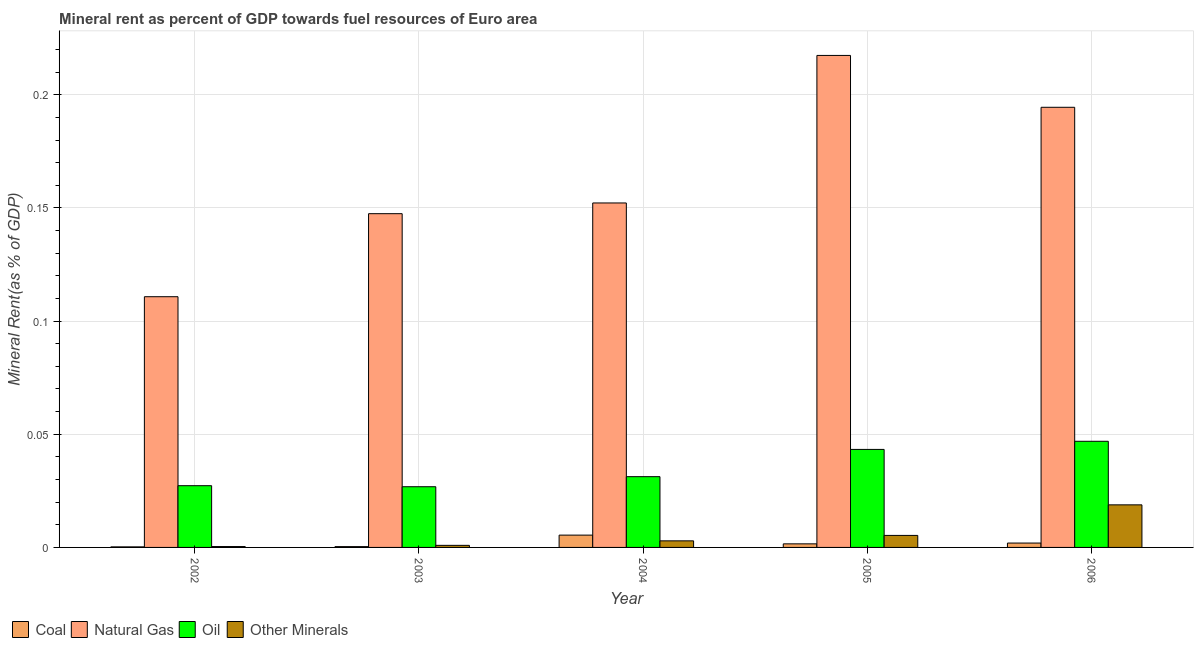How many different coloured bars are there?
Provide a short and direct response. 4. How many groups of bars are there?
Your answer should be very brief. 5. Are the number of bars on each tick of the X-axis equal?
Ensure brevity in your answer.  Yes. What is the  rent of other minerals in 2005?
Your answer should be compact. 0.01. Across all years, what is the maximum natural gas rent?
Your response must be concise. 0.22. Across all years, what is the minimum oil rent?
Your answer should be very brief. 0.03. What is the total natural gas rent in the graph?
Make the answer very short. 0.82. What is the difference between the natural gas rent in 2004 and that in 2006?
Keep it short and to the point. -0.04. What is the difference between the oil rent in 2002 and the  rent of other minerals in 2006?
Your answer should be compact. -0.02. What is the average  rent of other minerals per year?
Provide a short and direct response. 0.01. What is the ratio of the natural gas rent in 2003 to that in 2006?
Your answer should be compact. 0.76. What is the difference between the highest and the second highest  rent of other minerals?
Offer a very short reply. 0.01. What is the difference between the highest and the lowest oil rent?
Keep it short and to the point. 0.02. What does the 1st bar from the left in 2005 represents?
Provide a short and direct response. Coal. What does the 3rd bar from the right in 2006 represents?
Your answer should be very brief. Natural Gas. Are all the bars in the graph horizontal?
Provide a short and direct response. No. How many years are there in the graph?
Ensure brevity in your answer.  5. Does the graph contain any zero values?
Your response must be concise. No. Does the graph contain grids?
Offer a very short reply. Yes. What is the title of the graph?
Offer a terse response. Mineral rent as percent of GDP towards fuel resources of Euro area. What is the label or title of the X-axis?
Ensure brevity in your answer.  Year. What is the label or title of the Y-axis?
Make the answer very short. Mineral Rent(as % of GDP). What is the Mineral Rent(as % of GDP) in Coal in 2002?
Your response must be concise. 0. What is the Mineral Rent(as % of GDP) of Natural Gas in 2002?
Offer a terse response. 0.11. What is the Mineral Rent(as % of GDP) of Oil in 2002?
Give a very brief answer. 0.03. What is the Mineral Rent(as % of GDP) in Other Minerals in 2002?
Keep it short and to the point. 0. What is the Mineral Rent(as % of GDP) in Coal in 2003?
Provide a succinct answer. 0. What is the Mineral Rent(as % of GDP) of Natural Gas in 2003?
Your answer should be very brief. 0.15. What is the Mineral Rent(as % of GDP) of Oil in 2003?
Ensure brevity in your answer.  0.03. What is the Mineral Rent(as % of GDP) of Other Minerals in 2003?
Your response must be concise. 0. What is the Mineral Rent(as % of GDP) in Coal in 2004?
Ensure brevity in your answer.  0.01. What is the Mineral Rent(as % of GDP) of Natural Gas in 2004?
Provide a succinct answer. 0.15. What is the Mineral Rent(as % of GDP) of Oil in 2004?
Offer a very short reply. 0.03. What is the Mineral Rent(as % of GDP) in Other Minerals in 2004?
Keep it short and to the point. 0. What is the Mineral Rent(as % of GDP) in Coal in 2005?
Provide a succinct answer. 0. What is the Mineral Rent(as % of GDP) in Natural Gas in 2005?
Keep it short and to the point. 0.22. What is the Mineral Rent(as % of GDP) in Oil in 2005?
Your answer should be compact. 0.04. What is the Mineral Rent(as % of GDP) in Other Minerals in 2005?
Offer a terse response. 0.01. What is the Mineral Rent(as % of GDP) in Coal in 2006?
Provide a succinct answer. 0. What is the Mineral Rent(as % of GDP) of Natural Gas in 2006?
Provide a succinct answer. 0.19. What is the Mineral Rent(as % of GDP) in Oil in 2006?
Provide a succinct answer. 0.05. What is the Mineral Rent(as % of GDP) of Other Minerals in 2006?
Keep it short and to the point. 0.02. Across all years, what is the maximum Mineral Rent(as % of GDP) of Coal?
Your answer should be compact. 0.01. Across all years, what is the maximum Mineral Rent(as % of GDP) in Natural Gas?
Provide a succinct answer. 0.22. Across all years, what is the maximum Mineral Rent(as % of GDP) in Oil?
Keep it short and to the point. 0.05. Across all years, what is the maximum Mineral Rent(as % of GDP) in Other Minerals?
Provide a succinct answer. 0.02. Across all years, what is the minimum Mineral Rent(as % of GDP) in Coal?
Offer a terse response. 0. Across all years, what is the minimum Mineral Rent(as % of GDP) of Natural Gas?
Provide a succinct answer. 0.11. Across all years, what is the minimum Mineral Rent(as % of GDP) of Oil?
Offer a very short reply. 0.03. Across all years, what is the minimum Mineral Rent(as % of GDP) in Other Minerals?
Give a very brief answer. 0. What is the total Mineral Rent(as % of GDP) in Coal in the graph?
Keep it short and to the point. 0.01. What is the total Mineral Rent(as % of GDP) in Natural Gas in the graph?
Your response must be concise. 0.82. What is the total Mineral Rent(as % of GDP) in Oil in the graph?
Your answer should be compact. 0.18. What is the total Mineral Rent(as % of GDP) of Other Minerals in the graph?
Make the answer very short. 0.03. What is the difference between the Mineral Rent(as % of GDP) in Coal in 2002 and that in 2003?
Your answer should be very brief. -0. What is the difference between the Mineral Rent(as % of GDP) of Natural Gas in 2002 and that in 2003?
Give a very brief answer. -0.04. What is the difference between the Mineral Rent(as % of GDP) of Other Minerals in 2002 and that in 2003?
Provide a succinct answer. -0. What is the difference between the Mineral Rent(as % of GDP) of Coal in 2002 and that in 2004?
Give a very brief answer. -0.01. What is the difference between the Mineral Rent(as % of GDP) of Natural Gas in 2002 and that in 2004?
Provide a succinct answer. -0.04. What is the difference between the Mineral Rent(as % of GDP) in Oil in 2002 and that in 2004?
Ensure brevity in your answer.  -0. What is the difference between the Mineral Rent(as % of GDP) in Other Minerals in 2002 and that in 2004?
Your answer should be compact. -0. What is the difference between the Mineral Rent(as % of GDP) in Coal in 2002 and that in 2005?
Provide a succinct answer. -0. What is the difference between the Mineral Rent(as % of GDP) in Natural Gas in 2002 and that in 2005?
Provide a succinct answer. -0.11. What is the difference between the Mineral Rent(as % of GDP) of Oil in 2002 and that in 2005?
Your response must be concise. -0.02. What is the difference between the Mineral Rent(as % of GDP) of Other Minerals in 2002 and that in 2005?
Your answer should be very brief. -0. What is the difference between the Mineral Rent(as % of GDP) in Coal in 2002 and that in 2006?
Your answer should be very brief. -0. What is the difference between the Mineral Rent(as % of GDP) in Natural Gas in 2002 and that in 2006?
Make the answer very short. -0.08. What is the difference between the Mineral Rent(as % of GDP) in Oil in 2002 and that in 2006?
Your answer should be compact. -0.02. What is the difference between the Mineral Rent(as % of GDP) of Other Minerals in 2002 and that in 2006?
Offer a terse response. -0.02. What is the difference between the Mineral Rent(as % of GDP) in Coal in 2003 and that in 2004?
Your response must be concise. -0.01. What is the difference between the Mineral Rent(as % of GDP) in Natural Gas in 2003 and that in 2004?
Give a very brief answer. -0. What is the difference between the Mineral Rent(as % of GDP) of Oil in 2003 and that in 2004?
Your answer should be very brief. -0. What is the difference between the Mineral Rent(as % of GDP) in Other Minerals in 2003 and that in 2004?
Your answer should be very brief. -0. What is the difference between the Mineral Rent(as % of GDP) in Coal in 2003 and that in 2005?
Provide a short and direct response. -0. What is the difference between the Mineral Rent(as % of GDP) in Natural Gas in 2003 and that in 2005?
Your response must be concise. -0.07. What is the difference between the Mineral Rent(as % of GDP) in Oil in 2003 and that in 2005?
Offer a terse response. -0.02. What is the difference between the Mineral Rent(as % of GDP) of Other Minerals in 2003 and that in 2005?
Your answer should be compact. -0. What is the difference between the Mineral Rent(as % of GDP) of Coal in 2003 and that in 2006?
Offer a terse response. -0. What is the difference between the Mineral Rent(as % of GDP) of Natural Gas in 2003 and that in 2006?
Offer a terse response. -0.05. What is the difference between the Mineral Rent(as % of GDP) in Oil in 2003 and that in 2006?
Make the answer very short. -0.02. What is the difference between the Mineral Rent(as % of GDP) of Other Minerals in 2003 and that in 2006?
Your response must be concise. -0.02. What is the difference between the Mineral Rent(as % of GDP) in Coal in 2004 and that in 2005?
Keep it short and to the point. 0. What is the difference between the Mineral Rent(as % of GDP) of Natural Gas in 2004 and that in 2005?
Keep it short and to the point. -0.07. What is the difference between the Mineral Rent(as % of GDP) of Oil in 2004 and that in 2005?
Your answer should be very brief. -0.01. What is the difference between the Mineral Rent(as % of GDP) in Other Minerals in 2004 and that in 2005?
Make the answer very short. -0. What is the difference between the Mineral Rent(as % of GDP) of Coal in 2004 and that in 2006?
Offer a very short reply. 0. What is the difference between the Mineral Rent(as % of GDP) in Natural Gas in 2004 and that in 2006?
Your answer should be very brief. -0.04. What is the difference between the Mineral Rent(as % of GDP) of Oil in 2004 and that in 2006?
Give a very brief answer. -0.02. What is the difference between the Mineral Rent(as % of GDP) of Other Minerals in 2004 and that in 2006?
Keep it short and to the point. -0.02. What is the difference between the Mineral Rent(as % of GDP) of Coal in 2005 and that in 2006?
Offer a terse response. -0. What is the difference between the Mineral Rent(as % of GDP) of Natural Gas in 2005 and that in 2006?
Your response must be concise. 0.02. What is the difference between the Mineral Rent(as % of GDP) of Oil in 2005 and that in 2006?
Provide a short and direct response. -0. What is the difference between the Mineral Rent(as % of GDP) in Other Minerals in 2005 and that in 2006?
Keep it short and to the point. -0.01. What is the difference between the Mineral Rent(as % of GDP) of Coal in 2002 and the Mineral Rent(as % of GDP) of Natural Gas in 2003?
Your answer should be compact. -0.15. What is the difference between the Mineral Rent(as % of GDP) in Coal in 2002 and the Mineral Rent(as % of GDP) in Oil in 2003?
Keep it short and to the point. -0.03. What is the difference between the Mineral Rent(as % of GDP) of Coal in 2002 and the Mineral Rent(as % of GDP) of Other Minerals in 2003?
Your answer should be compact. -0. What is the difference between the Mineral Rent(as % of GDP) of Natural Gas in 2002 and the Mineral Rent(as % of GDP) of Oil in 2003?
Ensure brevity in your answer.  0.08. What is the difference between the Mineral Rent(as % of GDP) in Natural Gas in 2002 and the Mineral Rent(as % of GDP) in Other Minerals in 2003?
Your response must be concise. 0.11. What is the difference between the Mineral Rent(as % of GDP) of Oil in 2002 and the Mineral Rent(as % of GDP) of Other Minerals in 2003?
Give a very brief answer. 0.03. What is the difference between the Mineral Rent(as % of GDP) in Coal in 2002 and the Mineral Rent(as % of GDP) in Natural Gas in 2004?
Your answer should be very brief. -0.15. What is the difference between the Mineral Rent(as % of GDP) of Coal in 2002 and the Mineral Rent(as % of GDP) of Oil in 2004?
Ensure brevity in your answer.  -0.03. What is the difference between the Mineral Rent(as % of GDP) in Coal in 2002 and the Mineral Rent(as % of GDP) in Other Minerals in 2004?
Offer a very short reply. -0. What is the difference between the Mineral Rent(as % of GDP) in Natural Gas in 2002 and the Mineral Rent(as % of GDP) in Oil in 2004?
Offer a terse response. 0.08. What is the difference between the Mineral Rent(as % of GDP) in Natural Gas in 2002 and the Mineral Rent(as % of GDP) in Other Minerals in 2004?
Make the answer very short. 0.11. What is the difference between the Mineral Rent(as % of GDP) in Oil in 2002 and the Mineral Rent(as % of GDP) in Other Minerals in 2004?
Provide a succinct answer. 0.02. What is the difference between the Mineral Rent(as % of GDP) of Coal in 2002 and the Mineral Rent(as % of GDP) of Natural Gas in 2005?
Your response must be concise. -0.22. What is the difference between the Mineral Rent(as % of GDP) of Coal in 2002 and the Mineral Rent(as % of GDP) of Oil in 2005?
Your answer should be very brief. -0.04. What is the difference between the Mineral Rent(as % of GDP) of Coal in 2002 and the Mineral Rent(as % of GDP) of Other Minerals in 2005?
Your answer should be compact. -0.01. What is the difference between the Mineral Rent(as % of GDP) of Natural Gas in 2002 and the Mineral Rent(as % of GDP) of Oil in 2005?
Your answer should be compact. 0.07. What is the difference between the Mineral Rent(as % of GDP) in Natural Gas in 2002 and the Mineral Rent(as % of GDP) in Other Minerals in 2005?
Ensure brevity in your answer.  0.11. What is the difference between the Mineral Rent(as % of GDP) in Oil in 2002 and the Mineral Rent(as % of GDP) in Other Minerals in 2005?
Provide a succinct answer. 0.02. What is the difference between the Mineral Rent(as % of GDP) in Coal in 2002 and the Mineral Rent(as % of GDP) in Natural Gas in 2006?
Offer a very short reply. -0.19. What is the difference between the Mineral Rent(as % of GDP) in Coal in 2002 and the Mineral Rent(as % of GDP) in Oil in 2006?
Your answer should be very brief. -0.05. What is the difference between the Mineral Rent(as % of GDP) in Coal in 2002 and the Mineral Rent(as % of GDP) in Other Minerals in 2006?
Your answer should be very brief. -0.02. What is the difference between the Mineral Rent(as % of GDP) in Natural Gas in 2002 and the Mineral Rent(as % of GDP) in Oil in 2006?
Provide a succinct answer. 0.06. What is the difference between the Mineral Rent(as % of GDP) of Natural Gas in 2002 and the Mineral Rent(as % of GDP) of Other Minerals in 2006?
Provide a succinct answer. 0.09. What is the difference between the Mineral Rent(as % of GDP) in Oil in 2002 and the Mineral Rent(as % of GDP) in Other Minerals in 2006?
Provide a succinct answer. 0.01. What is the difference between the Mineral Rent(as % of GDP) of Coal in 2003 and the Mineral Rent(as % of GDP) of Natural Gas in 2004?
Your answer should be very brief. -0.15. What is the difference between the Mineral Rent(as % of GDP) of Coal in 2003 and the Mineral Rent(as % of GDP) of Oil in 2004?
Keep it short and to the point. -0.03. What is the difference between the Mineral Rent(as % of GDP) of Coal in 2003 and the Mineral Rent(as % of GDP) of Other Minerals in 2004?
Make the answer very short. -0. What is the difference between the Mineral Rent(as % of GDP) of Natural Gas in 2003 and the Mineral Rent(as % of GDP) of Oil in 2004?
Provide a succinct answer. 0.12. What is the difference between the Mineral Rent(as % of GDP) of Natural Gas in 2003 and the Mineral Rent(as % of GDP) of Other Minerals in 2004?
Give a very brief answer. 0.14. What is the difference between the Mineral Rent(as % of GDP) of Oil in 2003 and the Mineral Rent(as % of GDP) of Other Minerals in 2004?
Offer a very short reply. 0.02. What is the difference between the Mineral Rent(as % of GDP) of Coal in 2003 and the Mineral Rent(as % of GDP) of Natural Gas in 2005?
Your answer should be very brief. -0.22. What is the difference between the Mineral Rent(as % of GDP) in Coal in 2003 and the Mineral Rent(as % of GDP) in Oil in 2005?
Offer a very short reply. -0.04. What is the difference between the Mineral Rent(as % of GDP) in Coal in 2003 and the Mineral Rent(as % of GDP) in Other Minerals in 2005?
Keep it short and to the point. -0.01. What is the difference between the Mineral Rent(as % of GDP) of Natural Gas in 2003 and the Mineral Rent(as % of GDP) of Oil in 2005?
Offer a terse response. 0.1. What is the difference between the Mineral Rent(as % of GDP) of Natural Gas in 2003 and the Mineral Rent(as % of GDP) of Other Minerals in 2005?
Offer a terse response. 0.14. What is the difference between the Mineral Rent(as % of GDP) in Oil in 2003 and the Mineral Rent(as % of GDP) in Other Minerals in 2005?
Make the answer very short. 0.02. What is the difference between the Mineral Rent(as % of GDP) of Coal in 2003 and the Mineral Rent(as % of GDP) of Natural Gas in 2006?
Offer a very short reply. -0.19. What is the difference between the Mineral Rent(as % of GDP) in Coal in 2003 and the Mineral Rent(as % of GDP) in Oil in 2006?
Your response must be concise. -0.05. What is the difference between the Mineral Rent(as % of GDP) in Coal in 2003 and the Mineral Rent(as % of GDP) in Other Minerals in 2006?
Your answer should be compact. -0.02. What is the difference between the Mineral Rent(as % of GDP) of Natural Gas in 2003 and the Mineral Rent(as % of GDP) of Oil in 2006?
Your answer should be very brief. 0.1. What is the difference between the Mineral Rent(as % of GDP) of Natural Gas in 2003 and the Mineral Rent(as % of GDP) of Other Minerals in 2006?
Your answer should be very brief. 0.13. What is the difference between the Mineral Rent(as % of GDP) in Oil in 2003 and the Mineral Rent(as % of GDP) in Other Minerals in 2006?
Provide a short and direct response. 0.01. What is the difference between the Mineral Rent(as % of GDP) of Coal in 2004 and the Mineral Rent(as % of GDP) of Natural Gas in 2005?
Provide a short and direct response. -0.21. What is the difference between the Mineral Rent(as % of GDP) in Coal in 2004 and the Mineral Rent(as % of GDP) in Oil in 2005?
Your answer should be very brief. -0.04. What is the difference between the Mineral Rent(as % of GDP) of Coal in 2004 and the Mineral Rent(as % of GDP) of Other Minerals in 2005?
Offer a terse response. 0. What is the difference between the Mineral Rent(as % of GDP) in Natural Gas in 2004 and the Mineral Rent(as % of GDP) in Oil in 2005?
Provide a short and direct response. 0.11. What is the difference between the Mineral Rent(as % of GDP) of Natural Gas in 2004 and the Mineral Rent(as % of GDP) of Other Minerals in 2005?
Your answer should be compact. 0.15. What is the difference between the Mineral Rent(as % of GDP) of Oil in 2004 and the Mineral Rent(as % of GDP) of Other Minerals in 2005?
Offer a very short reply. 0.03. What is the difference between the Mineral Rent(as % of GDP) of Coal in 2004 and the Mineral Rent(as % of GDP) of Natural Gas in 2006?
Provide a short and direct response. -0.19. What is the difference between the Mineral Rent(as % of GDP) in Coal in 2004 and the Mineral Rent(as % of GDP) in Oil in 2006?
Your response must be concise. -0.04. What is the difference between the Mineral Rent(as % of GDP) of Coal in 2004 and the Mineral Rent(as % of GDP) of Other Minerals in 2006?
Make the answer very short. -0.01. What is the difference between the Mineral Rent(as % of GDP) of Natural Gas in 2004 and the Mineral Rent(as % of GDP) of Oil in 2006?
Offer a very short reply. 0.11. What is the difference between the Mineral Rent(as % of GDP) of Natural Gas in 2004 and the Mineral Rent(as % of GDP) of Other Minerals in 2006?
Ensure brevity in your answer.  0.13. What is the difference between the Mineral Rent(as % of GDP) of Oil in 2004 and the Mineral Rent(as % of GDP) of Other Minerals in 2006?
Your response must be concise. 0.01. What is the difference between the Mineral Rent(as % of GDP) in Coal in 2005 and the Mineral Rent(as % of GDP) in Natural Gas in 2006?
Your response must be concise. -0.19. What is the difference between the Mineral Rent(as % of GDP) of Coal in 2005 and the Mineral Rent(as % of GDP) of Oil in 2006?
Provide a short and direct response. -0.05. What is the difference between the Mineral Rent(as % of GDP) of Coal in 2005 and the Mineral Rent(as % of GDP) of Other Minerals in 2006?
Offer a very short reply. -0.02. What is the difference between the Mineral Rent(as % of GDP) of Natural Gas in 2005 and the Mineral Rent(as % of GDP) of Oil in 2006?
Provide a succinct answer. 0.17. What is the difference between the Mineral Rent(as % of GDP) in Natural Gas in 2005 and the Mineral Rent(as % of GDP) in Other Minerals in 2006?
Make the answer very short. 0.2. What is the difference between the Mineral Rent(as % of GDP) in Oil in 2005 and the Mineral Rent(as % of GDP) in Other Minerals in 2006?
Your answer should be compact. 0.02. What is the average Mineral Rent(as % of GDP) in Coal per year?
Offer a terse response. 0. What is the average Mineral Rent(as % of GDP) of Natural Gas per year?
Ensure brevity in your answer.  0.16. What is the average Mineral Rent(as % of GDP) of Oil per year?
Offer a very short reply. 0.04. What is the average Mineral Rent(as % of GDP) in Other Minerals per year?
Give a very brief answer. 0.01. In the year 2002, what is the difference between the Mineral Rent(as % of GDP) of Coal and Mineral Rent(as % of GDP) of Natural Gas?
Provide a short and direct response. -0.11. In the year 2002, what is the difference between the Mineral Rent(as % of GDP) in Coal and Mineral Rent(as % of GDP) in Oil?
Give a very brief answer. -0.03. In the year 2002, what is the difference between the Mineral Rent(as % of GDP) of Coal and Mineral Rent(as % of GDP) of Other Minerals?
Make the answer very short. -0. In the year 2002, what is the difference between the Mineral Rent(as % of GDP) of Natural Gas and Mineral Rent(as % of GDP) of Oil?
Give a very brief answer. 0.08. In the year 2002, what is the difference between the Mineral Rent(as % of GDP) in Natural Gas and Mineral Rent(as % of GDP) in Other Minerals?
Ensure brevity in your answer.  0.11. In the year 2002, what is the difference between the Mineral Rent(as % of GDP) of Oil and Mineral Rent(as % of GDP) of Other Minerals?
Keep it short and to the point. 0.03. In the year 2003, what is the difference between the Mineral Rent(as % of GDP) in Coal and Mineral Rent(as % of GDP) in Natural Gas?
Keep it short and to the point. -0.15. In the year 2003, what is the difference between the Mineral Rent(as % of GDP) in Coal and Mineral Rent(as % of GDP) in Oil?
Make the answer very short. -0.03. In the year 2003, what is the difference between the Mineral Rent(as % of GDP) in Coal and Mineral Rent(as % of GDP) in Other Minerals?
Ensure brevity in your answer.  -0. In the year 2003, what is the difference between the Mineral Rent(as % of GDP) of Natural Gas and Mineral Rent(as % of GDP) of Oil?
Offer a terse response. 0.12. In the year 2003, what is the difference between the Mineral Rent(as % of GDP) of Natural Gas and Mineral Rent(as % of GDP) of Other Minerals?
Give a very brief answer. 0.15. In the year 2003, what is the difference between the Mineral Rent(as % of GDP) of Oil and Mineral Rent(as % of GDP) of Other Minerals?
Offer a terse response. 0.03. In the year 2004, what is the difference between the Mineral Rent(as % of GDP) in Coal and Mineral Rent(as % of GDP) in Natural Gas?
Give a very brief answer. -0.15. In the year 2004, what is the difference between the Mineral Rent(as % of GDP) in Coal and Mineral Rent(as % of GDP) in Oil?
Offer a terse response. -0.03. In the year 2004, what is the difference between the Mineral Rent(as % of GDP) in Coal and Mineral Rent(as % of GDP) in Other Minerals?
Provide a succinct answer. 0. In the year 2004, what is the difference between the Mineral Rent(as % of GDP) of Natural Gas and Mineral Rent(as % of GDP) of Oil?
Ensure brevity in your answer.  0.12. In the year 2004, what is the difference between the Mineral Rent(as % of GDP) in Natural Gas and Mineral Rent(as % of GDP) in Other Minerals?
Offer a terse response. 0.15. In the year 2004, what is the difference between the Mineral Rent(as % of GDP) in Oil and Mineral Rent(as % of GDP) in Other Minerals?
Make the answer very short. 0.03. In the year 2005, what is the difference between the Mineral Rent(as % of GDP) in Coal and Mineral Rent(as % of GDP) in Natural Gas?
Provide a short and direct response. -0.22. In the year 2005, what is the difference between the Mineral Rent(as % of GDP) in Coal and Mineral Rent(as % of GDP) in Oil?
Offer a terse response. -0.04. In the year 2005, what is the difference between the Mineral Rent(as % of GDP) of Coal and Mineral Rent(as % of GDP) of Other Minerals?
Your answer should be compact. -0. In the year 2005, what is the difference between the Mineral Rent(as % of GDP) of Natural Gas and Mineral Rent(as % of GDP) of Oil?
Provide a succinct answer. 0.17. In the year 2005, what is the difference between the Mineral Rent(as % of GDP) in Natural Gas and Mineral Rent(as % of GDP) in Other Minerals?
Your answer should be compact. 0.21. In the year 2005, what is the difference between the Mineral Rent(as % of GDP) in Oil and Mineral Rent(as % of GDP) in Other Minerals?
Give a very brief answer. 0.04. In the year 2006, what is the difference between the Mineral Rent(as % of GDP) of Coal and Mineral Rent(as % of GDP) of Natural Gas?
Make the answer very short. -0.19. In the year 2006, what is the difference between the Mineral Rent(as % of GDP) of Coal and Mineral Rent(as % of GDP) of Oil?
Your answer should be very brief. -0.04. In the year 2006, what is the difference between the Mineral Rent(as % of GDP) of Coal and Mineral Rent(as % of GDP) of Other Minerals?
Your response must be concise. -0.02. In the year 2006, what is the difference between the Mineral Rent(as % of GDP) in Natural Gas and Mineral Rent(as % of GDP) in Oil?
Provide a succinct answer. 0.15. In the year 2006, what is the difference between the Mineral Rent(as % of GDP) in Natural Gas and Mineral Rent(as % of GDP) in Other Minerals?
Keep it short and to the point. 0.18. In the year 2006, what is the difference between the Mineral Rent(as % of GDP) of Oil and Mineral Rent(as % of GDP) of Other Minerals?
Offer a terse response. 0.03. What is the ratio of the Mineral Rent(as % of GDP) of Coal in 2002 to that in 2003?
Provide a succinct answer. 0.69. What is the ratio of the Mineral Rent(as % of GDP) of Natural Gas in 2002 to that in 2003?
Offer a terse response. 0.75. What is the ratio of the Mineral Rent(as % of GDP) in Other Minerals in 2002 to that in 2003?
Keep it short and to the point. 0.42. What is the ratio of the Mineral Rent(as % of GDP) in Coal in 2002 to that in 2004?
Your answer should be very brief. 0.05. What is the ratio of the Mineral Rent(as % of GDP) of Natural Gas in 2002 to that in 2004?
Offer a very short reply. 0.73. What is the ratio of the Mineral Rent(as % of GDP) in Oil in 2002 to that in 2004?
Provide a short and direct response. 0.87. What is the ratio of the Mineral Rent(as % of GDP) in Other Minerals in 2002 to that in 2004?
Your answer should be very brief. 0.13. What is the ratio of the Mineral Rent(as % of GDP) of Coal in 2002 to that in 2005?
Offer a very short reply. 0.16. What is the ratio of the Mineral Rent(as % of GDP) of Natural Gas in 2002 to that in 2005?
Your answer should be very brief. 0.51. What is the ratio of the Mineral Rent(as % of GDP) in Oil in 2002 to that in 2005?
Your answer should be very brief. 0.63. What is the ratio of the Mineral Rent(as % of GDP) in Other Minerals in 2002 to that in 2005?
Provide a succinct answer. 0.07. What is the ratio of the Mineral Rent(as % of GDP) in Coal in 2002 to that in 2006?
Your answer should be compact. 0.13. What is the ratio of the Mineral Rent(as % of GDP) in Natural Gas in 2002 to that in 2006?
Provide a short and direct response. 0.57. What is the ratio of the Mineral Rent(as % of GDP) of Oil in 2002 to that in 2006?
Provide a short and direct response. 0.58. What is the ratio of the Mineral Rent(as % of GDP) of Other Minerals in 2002 to that in 2006?
Ensure brevity in your answer.  0.02. What is the ratio of the Mineral Rent(as % of GDP) of Coal in 2003 to that in 2004?
Make the answer very short. 0.07. What is the ratio of the Mineral Rent(as % of GDP) in Natural Gas in 2003 to that in 2004?
Give a very brief answer. 0.97. What is the ratio of the Mineral Rent(as % of GDP) of Oil in 2003 to that in 2004?
Provide a short and direct response. 0.86. What is the ratio of the Mineral Rent(as % of GDP) of Other Minerals in 2003 to that in 2004?
Offer a very short reply. 0.32. What is the ratio of the Mineral Rent(as % of GDP) of Coal in 2003 to that in 2005?
Your response must be concise. 0.23. What is the ratio of the Mineral Rent(as % of GDP) in Natural Gas in 2003 to that in 2005?
Your response must be concise. 0.68. What is the ratio of the Mineral Rent(as % of GDP) in Oil in 2003 to that in 2005?
Offer a very short reply. 0.62. What is the ratio of the Mineral Rent(as % of GDP) of Other Minerals in 2003 to that in 2005?
Your response must be concise. 0.17. What is the ratio of the Mineral Rent(as % of GDP) of Coal in 2003 to that in 2006?
Your answer should be compact. 0.18. What is the ratio of the Mineral Rent(as % of GDP) of Natural Gas in 2003 to that in 2006?
Offer a terse response. 0.76. What is the ratio of the Mineral Rent(as % of GDP) in Oil in 2003 to that in 2006?
Provide a short and direct response. 0.57. What is the ratio of the Mineral Rent(as % of GDP) of Other Minerals in 2003 to that in 2006?
Provide a short and direct response. 0.05. What is the ratio of the Mineral Rent(as % of GDP) in Coal in 2004 to that in 2005?
Your response must be concise. 3.44. What is the ratio of the Mineral Rent(as % of GDP) in Natural Gas in 2004 to that in 2005?
Ensure brevity in your answer.  0.7. What is the ratio of the Mineral Rent(as % of GDP) of Oil in 2004 to that in 2005?
Provide a short and direct response. 0.72. What is the ratio of the Mineral Rent(as % of GDP) in Other Minerals in 2004 to that in 2005?
Provide a succinct answer. 0.55. What is the ratio of the Mineral Rent(as % of GDP) of Coal in 2004 to that in 2006?
Offer a terse response. 2.81. What is the ratio of the Mineral Rent(as % of GDP) in Natural Gas in 2004 to that in 2006?
Your response must be concise. 0.78. What is the ratio of the Mineral Rent(as % of GDP) in Oil in 2004 to that in 2006?
Ensure brevity in your answer.  0.67. What is the ratio of the Mineral Rent(as % of GDP) in Other Minerals in 2004 to that in 2006?
Your answer should be very brief. 0.15. What is the ratio of the Mineral Rent(as % of GDP) in Coal in 2005 to that in 2006?
Your answer should be compact. 0.82. What is the ratio of the Mineral Rent(as % of GDP) in Natural Gas in 2005 to that in 2006?
Provide a short and direct response. 1.12. What is the ratio of the Mineral Rent(as % of GDP) of Oil in 2005 to that in 2006?
Ensure brevity in your answer.  0.92. What is the ratio of the Mineral Rent(as % of GDP) in Other Minerals in 2005 to that in 2006?
Ensure brevity in your answer.  0.28. What is the difference between the highest and the second highest Mineral Rent(as % of GDP) in Coal?
Make the answer very short. 0. What is the difference between the highest and the second highest Mineral Rent(as % of GDP) of Natural Gas?
Your answer should be very brief. 0.02. What is the difference between the highest and the second highest Mineral Rent(as % of GDP) of Oil?
Keep it short and to the point. 0. What is the difference between the highest and the second highest Mineral Rent(as % of GDP) in Other Minerals?
Keep it short and to the point. 0.01. What is the difference between the highest and the lowest Mineral Rent(as % of GDP) in Coal?
Give a very brief answer. 0.01. What is the difference between the highest and the lowest Mineral Rent(as % of GDP) of Natural Gas?
Your answer should be compact. 0.11. What is the difference between the highest and the lowest Mineral Rent(as % of GDP) of Oil?
Offer a very short reply. 0.02. What is the difference between the highest and the lowest Mineral Rent(as % of GDP) of Other Minerals?
Provide a succinct answer. 0.02. 